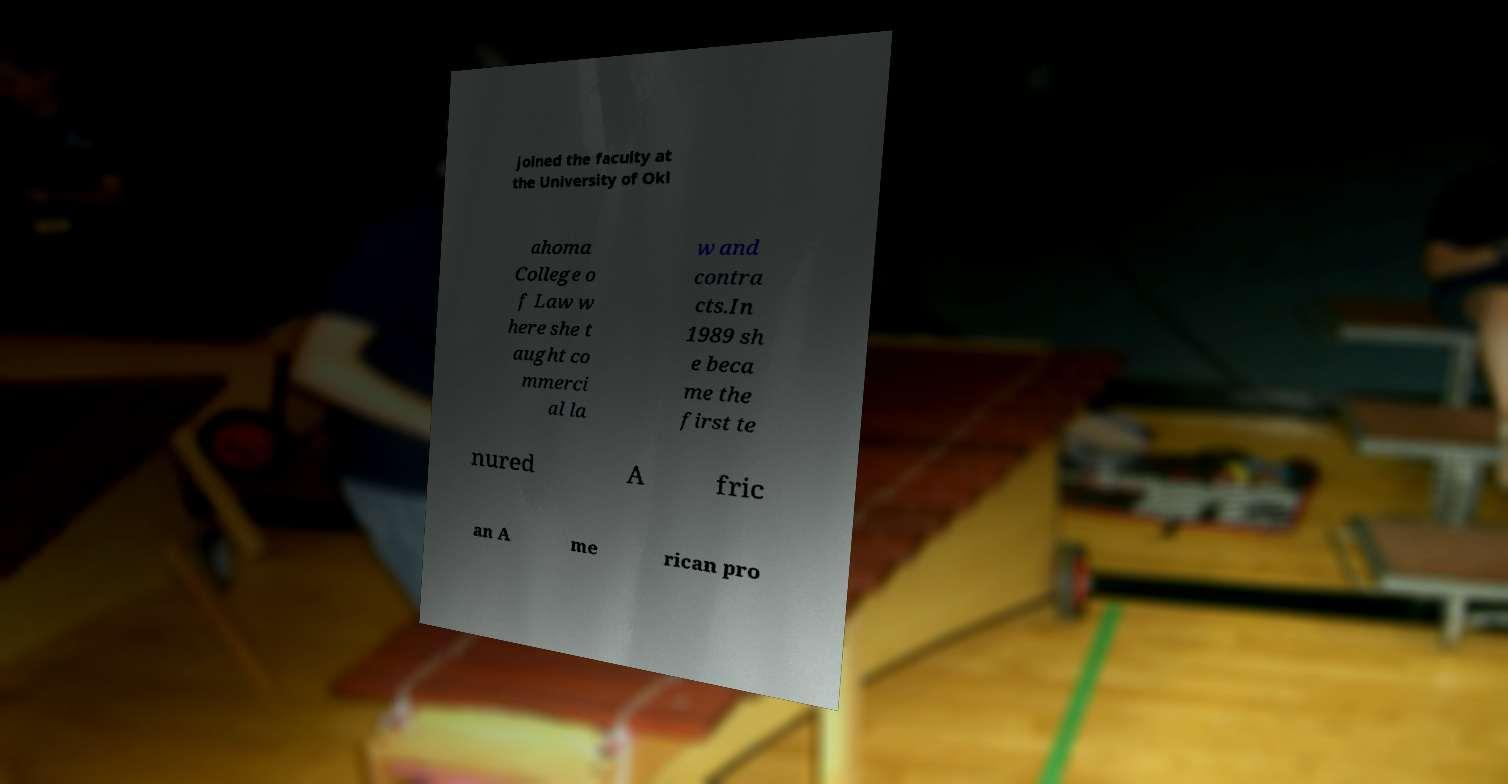For documentation purposes, I need the text within this image transcribed. Could you provide that? joined the faculty at the University of Okl ahoma College o f Law w here she t aught co mmerci al la w and contra cts.In 1989 sh e beca me the first te nured A fric an A me rican pro 